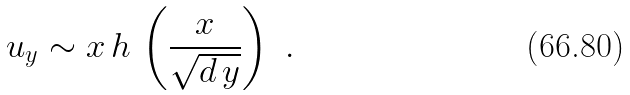Convert formula to latex. <formula><loc_0><loc_0><loc_500><loc_500>u _ { y } \sim x \, h \, \left ( \frac { x } { \sqrt { d \, y } } \right ) \ .</formula> 